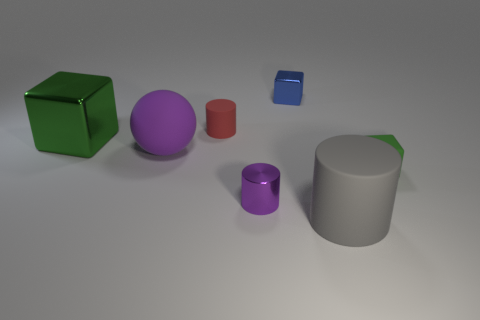What number of other objects are the same color as the small rubber cylinder?
Your response must be concise. 0. Is there any other thing that has the same size as the green matte cube?
Offer a terse response. Yes. There is a cube on the left side of the blue metal cube; is its size the same as the red object?
Your answer should be compact. No. What is the large gray cylinder that is in front of the green rubber object made of?
Make the answer very short. Rubber. Is there anything else that has the same shape as the small blue object?
Your answer should be very brief. Yes. How many matte things are either yellow cylinders or tiny green objects?
Make the answer very short. 1. Is the number of small metal cubes on the right side of the big gray matte object less than the number of purple rubber things?
Give a very brief answer. Yes. What shape is the large rubber thing behind the rubber thing that is in front of the green block right of the green metal cube?
Your response must be concise. Sphere. Do the rubber block and the large metal object have the same color?
Ensure brevity in your answer.  Yes. Are there more metallic cylinders than small red shiny spheres?
Provide a short and direct response. Yes. 